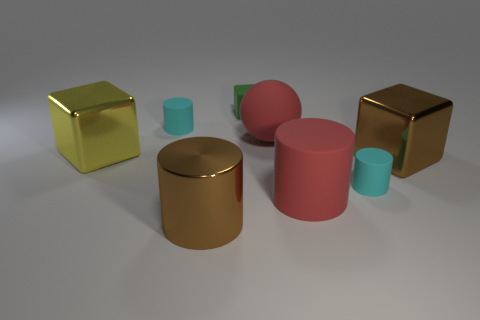What number of objects are either blue cylinders or brown cubes?
Make the answer very short. 1. How many other objects are there of the same color as the rubber sphere?
Provide a short and direct response. 1. There is a brown metallic object that is the same size as the brown metallic cylinder; what is its shape?
Make the answer very short. Cube. There is a large thing that is behind the yellow metal object; what is its color?
Offer a terse response. Red. What number of objects are either things that are in front of the yellow metal block or objects to the right of the brown cylinder?
Make the answer very short. 6. Do the matte sphere and the green rubber cube have the same size?
Your answer should be compact. No. What number of cubes are either big brown shiny objects or large metallic things?
Your answer should be compact. 2. What number of objects are left of the green matte thing and behind the big brown shiny cube?
Make the answer very short. 2. Do the red rubber cylinder and the metal block right of the rubber ball have the same size?
Make the answer very short. Yes. There is a large matte object that is left of the large red object in front of the yellow metallic block; is there a small object that is left of it?
Your response must be concise. Yes. 